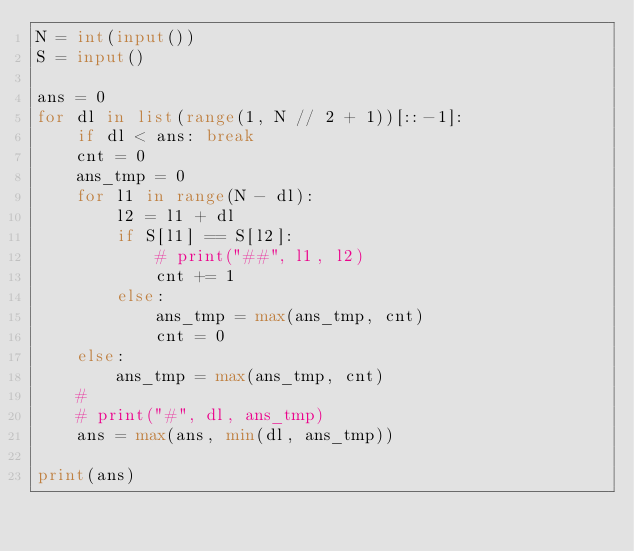<code> <loc_0><loc_0><loc_500><loc_500><_Python_>N = int(input())
S = input()

ans = 0
for dl in list(range(1, N // 2 + 1))[::-1]:
    if dl < ans: break
    cnt = 0
    ans_tmp = 0
    for l1 in range(N - dl):
        l2 = l1 + dl
        if S[l1] == S[l2]:
            # print("##", l1, l2)
            cnt += 1
        else:
            ans_tmp = max(ans_tmp, cnt)
            cnt = 0
    else:
        ans_tmp = max(ans_tmp, cnt)
    #
    # print("#", dl, ans_tmp)
    ans = max(ans, min(dl, ans_tmp))

print(ans)</code> 